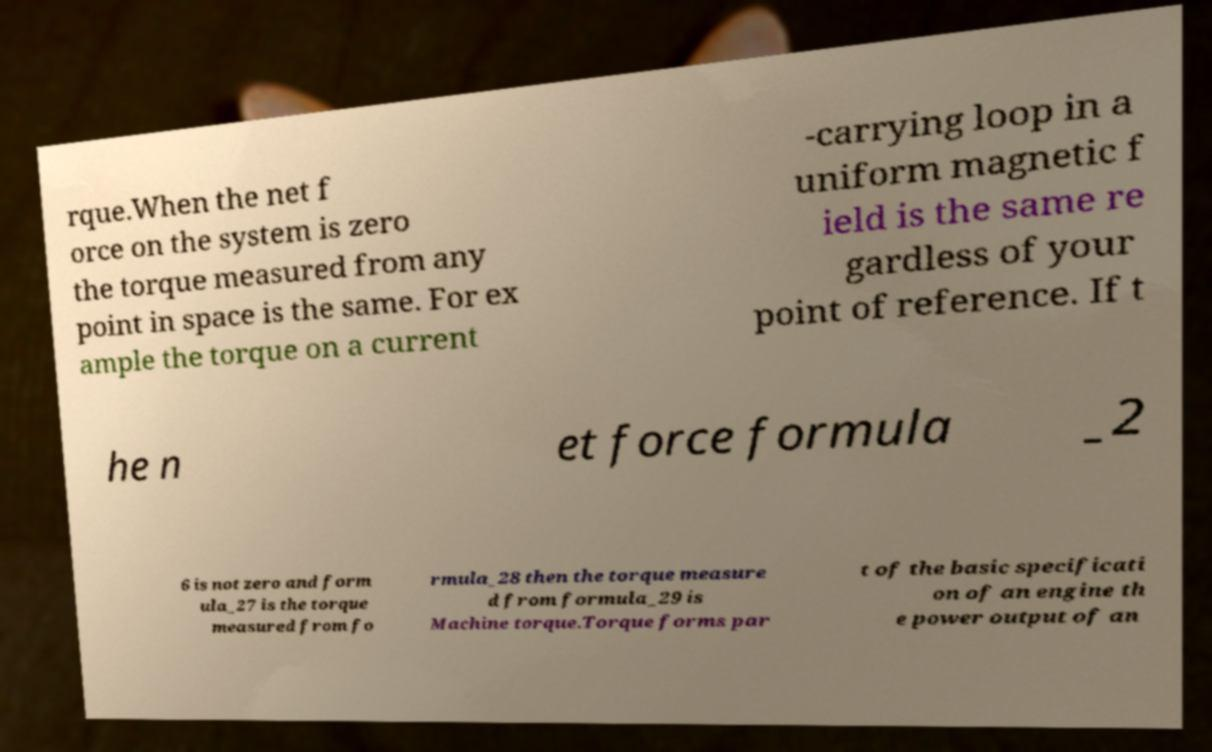There's text embedded in this image that I need extracted. Can you transcribe it verbatim? rque.When the net f orce on the system is zero the torque measured from any point in space is the same. For ex ample the torque on a current -carrying loop in a uniform magnetic f ield is the same re gardless of your point of reference. If t he n et force formula _2 6 is not zero and form ula_27 is the torque measured from fo rmula_28 then the torque measure d from formula_29 is Machine torque.Torque forms par t of the basic specificati on of an engine th e power output of an 